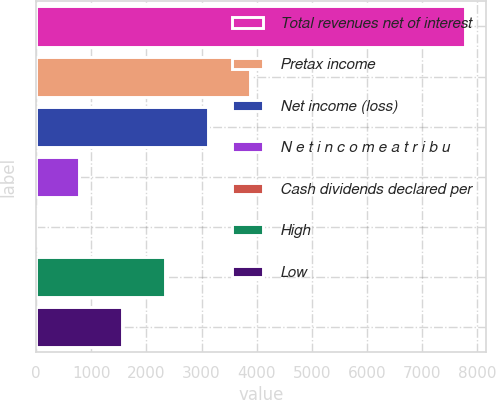Convert chart. <chart><loc_0><loc_0><loc_500><loc_500><bar_chart><fcel>Total revenues net of interest<fcel>Pretax income<fcel>Net income (loss)<fcel>N e t i n c o m e a t r i b u<fcel>Cash dividends declared per<fcel>High<fcel>Low<nl><fcel>7774<fcel>3887.17<fcel>3109.8<fcel>777.69<fcel>0.32<fcel>2332.43<fcel>1555.06<nl></chart> 